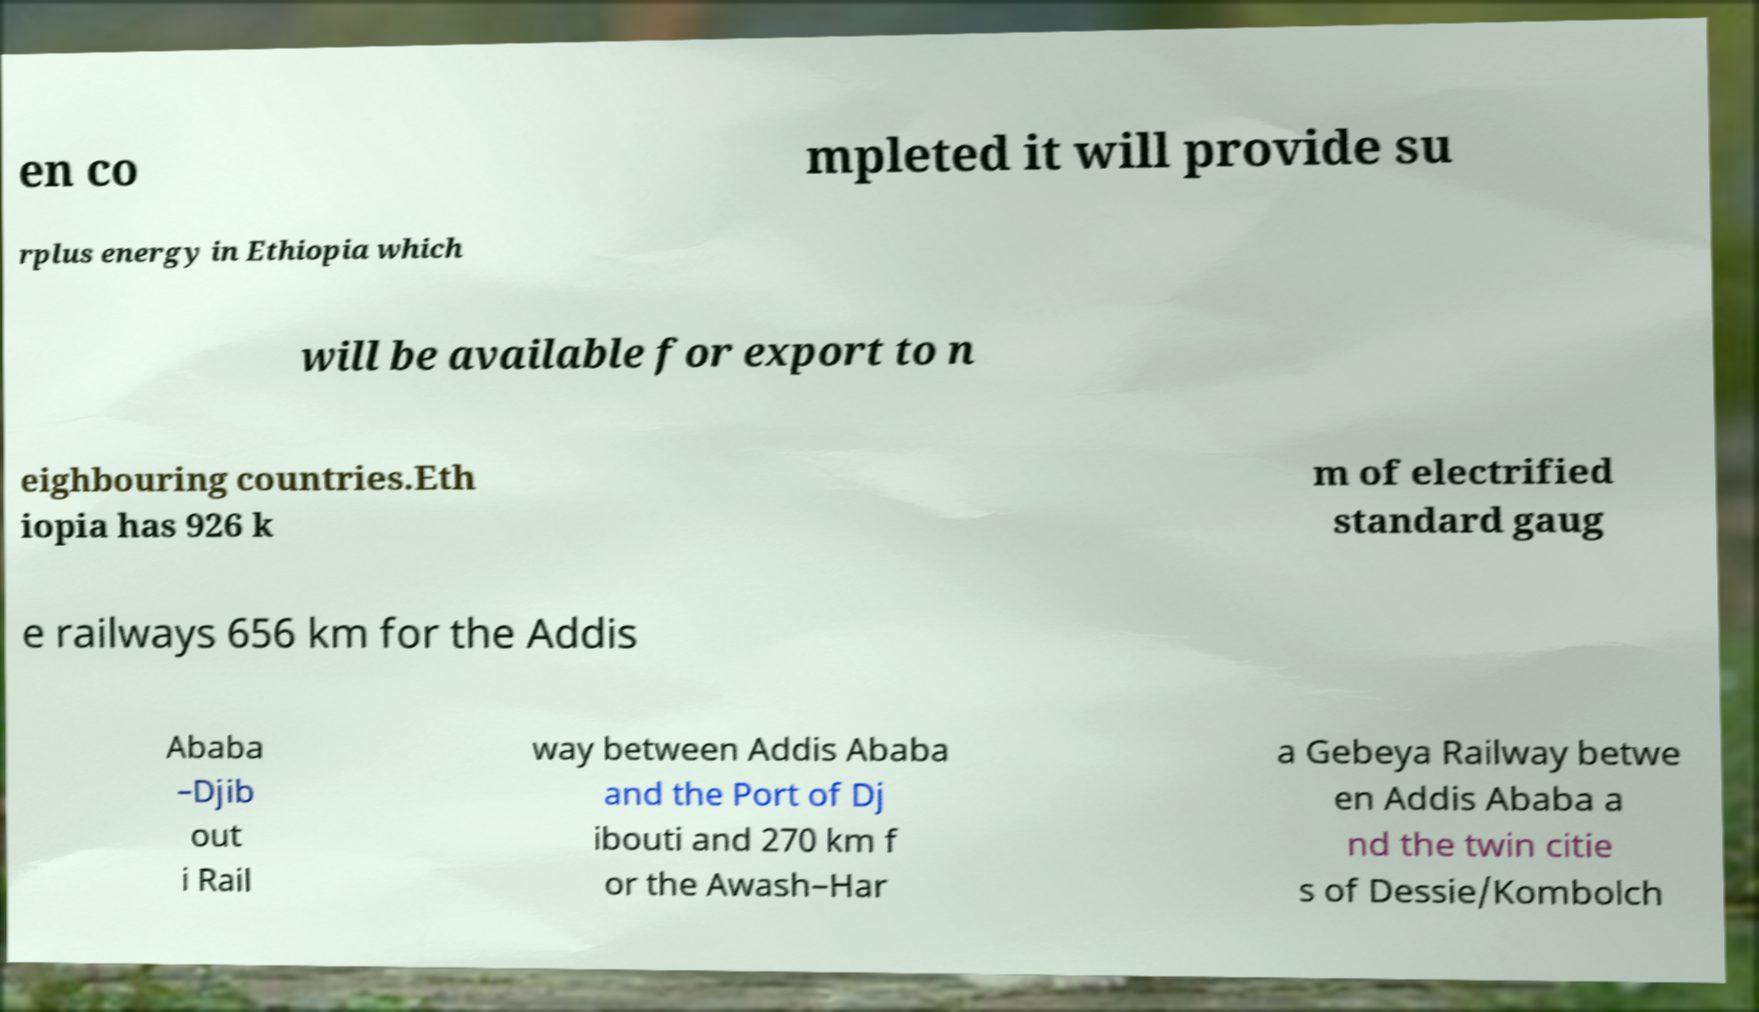Could you extract and type out the text from this image? en co mpleted it will provide su rplus energy in Ethiopia which will be available for export to n eighbouring countries.Eth iopia has 926 k m of electrified standard gaug e railways 656 km for the Addis Ababa –Djib out i Rail way between Addis Ababa and the Port of Dj ibouti and 270 km f or the Awash–Har a Gebeya Railway betwe en Addis Ababa a nd the twin citie s of Dessie/Kombolch 